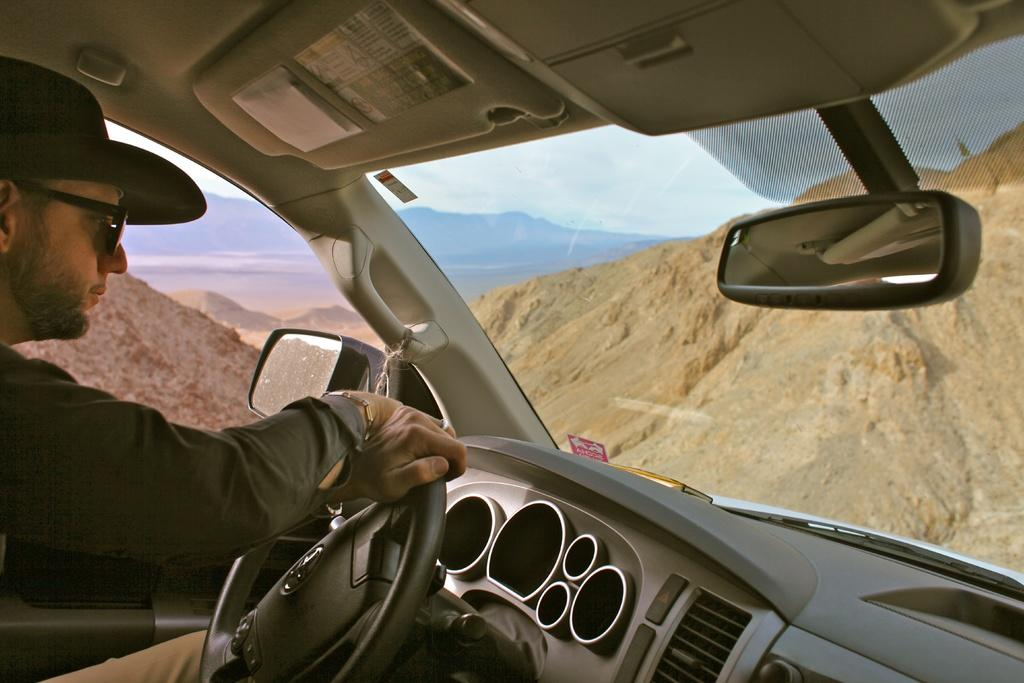What is the person in the image doing? The person in the image is driving a car. What can be seen in the background of the image? There are mountains visible in the background of the image. What type of drug is the person in the image using? There is no indication in the image that the person is using any drug. 